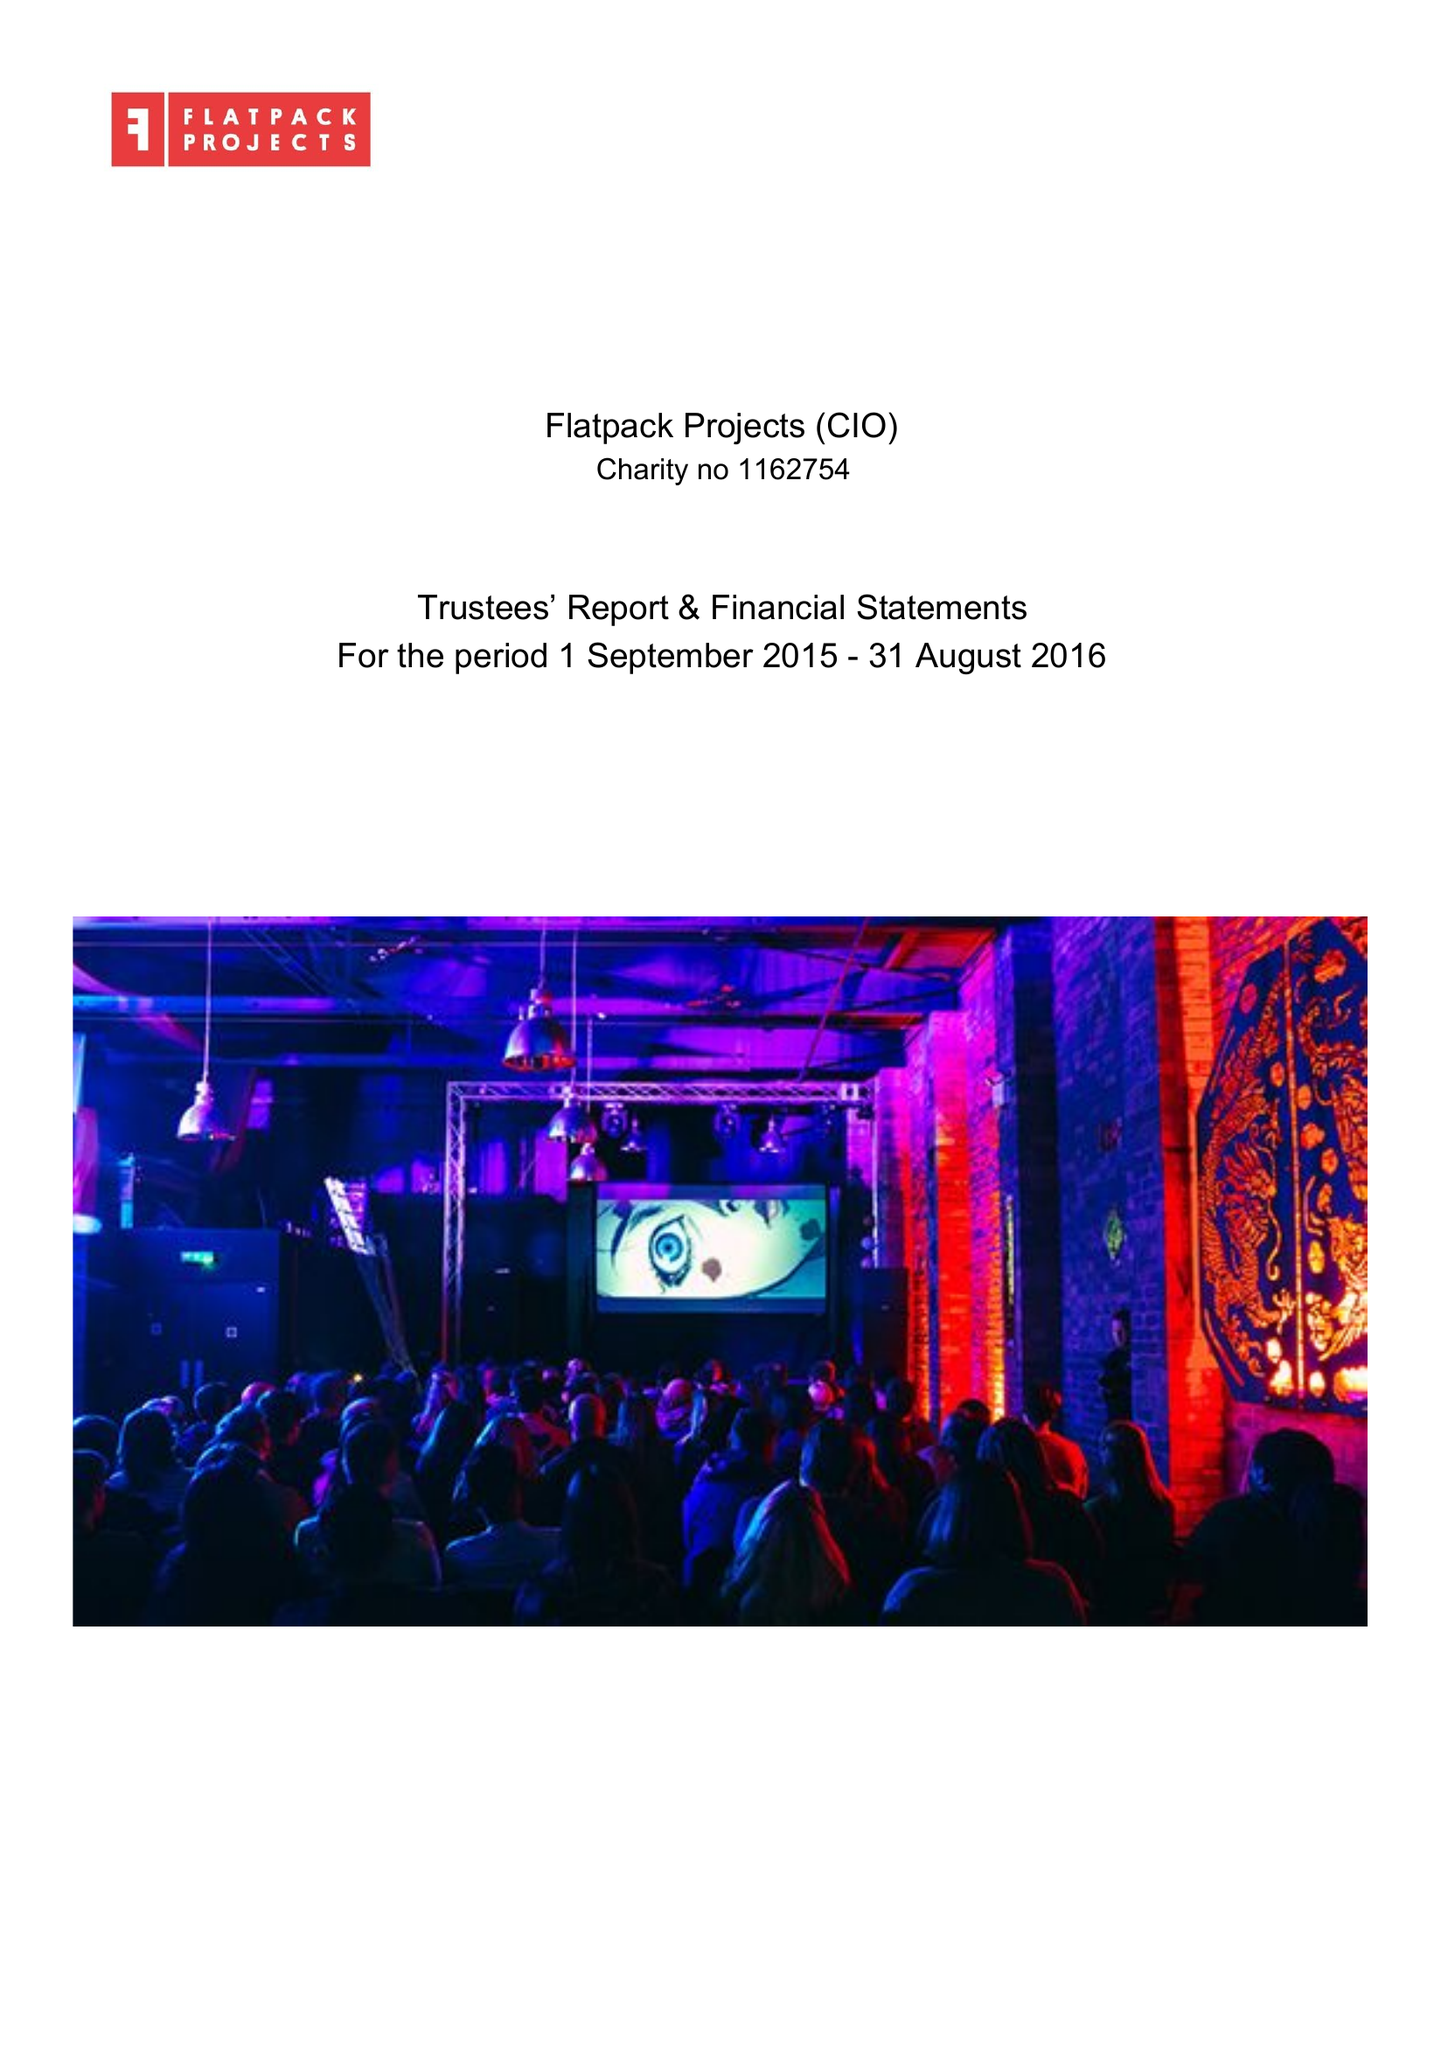What is the value for the charity_name?
Answer the question using a single word or phrase. Flatpack Projects 